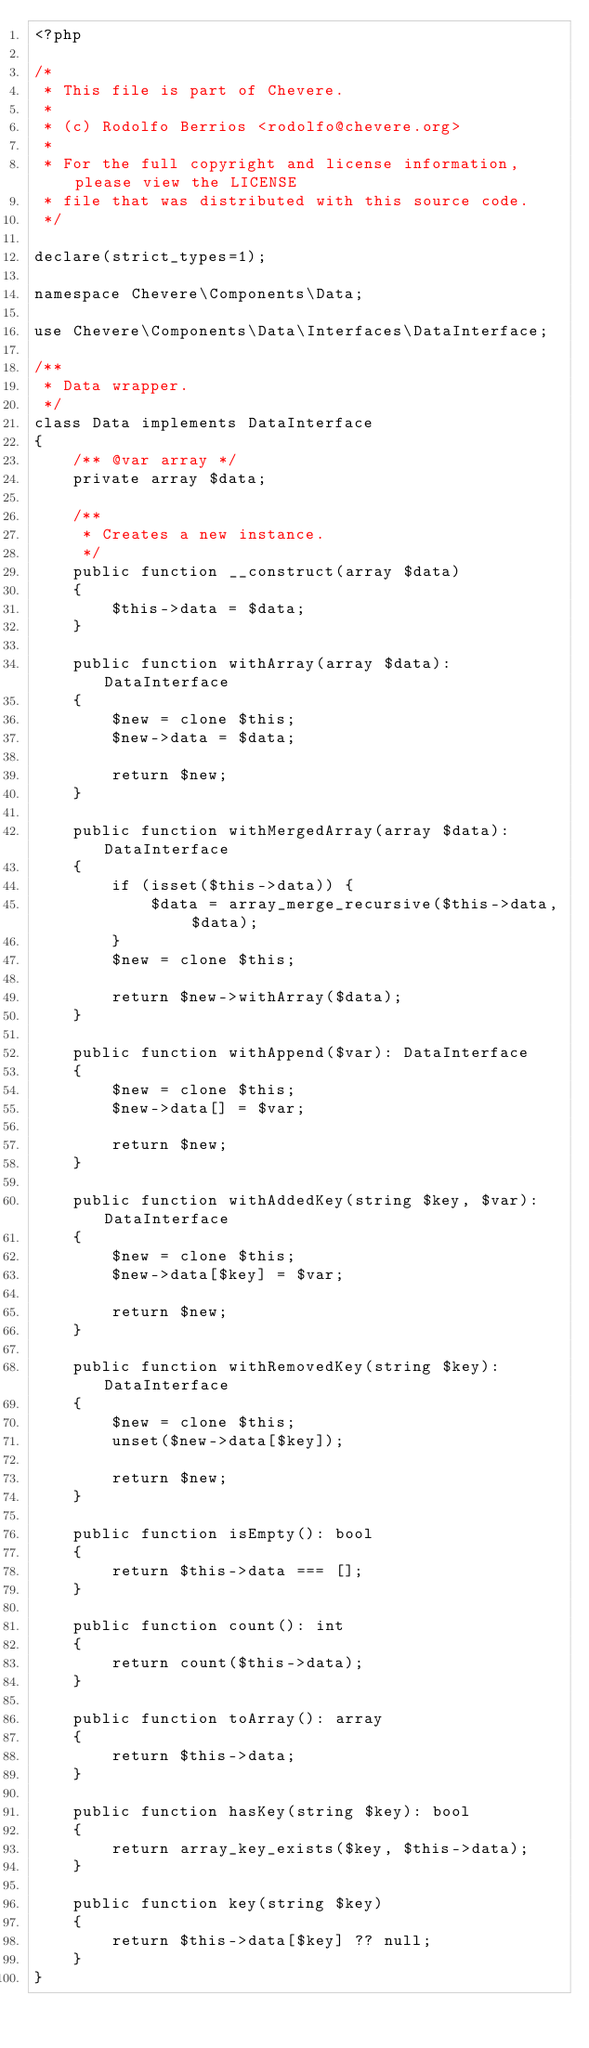<code> <loc_0><loc_0><loc_500><loc_500><_PHP_><?php

/*
 * This file is part of Chevere.
 *
 * (c) Rodolfo Berrios <rodolfo@chevere.org>
 *
 * For the full copyright and license information, please view the LICENSE
 * file that was distributed with this source code.
 */

declare(strict_types=1);

namespace Chevere\Components\Data;

use Chevere\Components\Data\Interfaces\DataInterface;

/**
 * Data wrapper.
 */
class Data implements DataInterface
{
    /** @var array */
    private array $data;

    /**
     * Creates a new instance.
     */
    public function __construct(array $data)
    {
        $this->data = $data;
    }

    public function withArray(array $data): DataInterface
    {
        $new = clone $this;
        $new->data = $data;

        return $new;
    }

    public function withMergedArray(array $data): DataInterface
    {
        if (isset($this->data)) {
            $data = array_merge_recursive($this->data, $data);
        }
        $new = clone $this;

        return $new->withArray($data);
    }

    public function withAppend($var): DataInterface
    {
        $new = clone $this;
        $new->data[] = $var;

        return $new;
    }

    public function withAddedKey(string $key, $var): DataInterface
    {
        $new = clone $this;
        $new->data[$key] = $var;

        return $new;
    }

    public function withRemovedKey(string $key): DataInterface
    {
        $new = clone $this;
        unset($new->data[$key]);

        return $new;
    }

    public function isEmpty(): bool
    {
        return $this->data === [];
    }

    public function count(): int
    {
        return count($this->data);
    }

    public function toArray(): array
    {
        return $this->data;
    }

    public function hasKey(string $key): bool
    {
        return array_key_exists($key, $this->data);
    }

    public function key(string $key)
    {
        return $this->data[$key] ?? null;
    }
}
</code> 